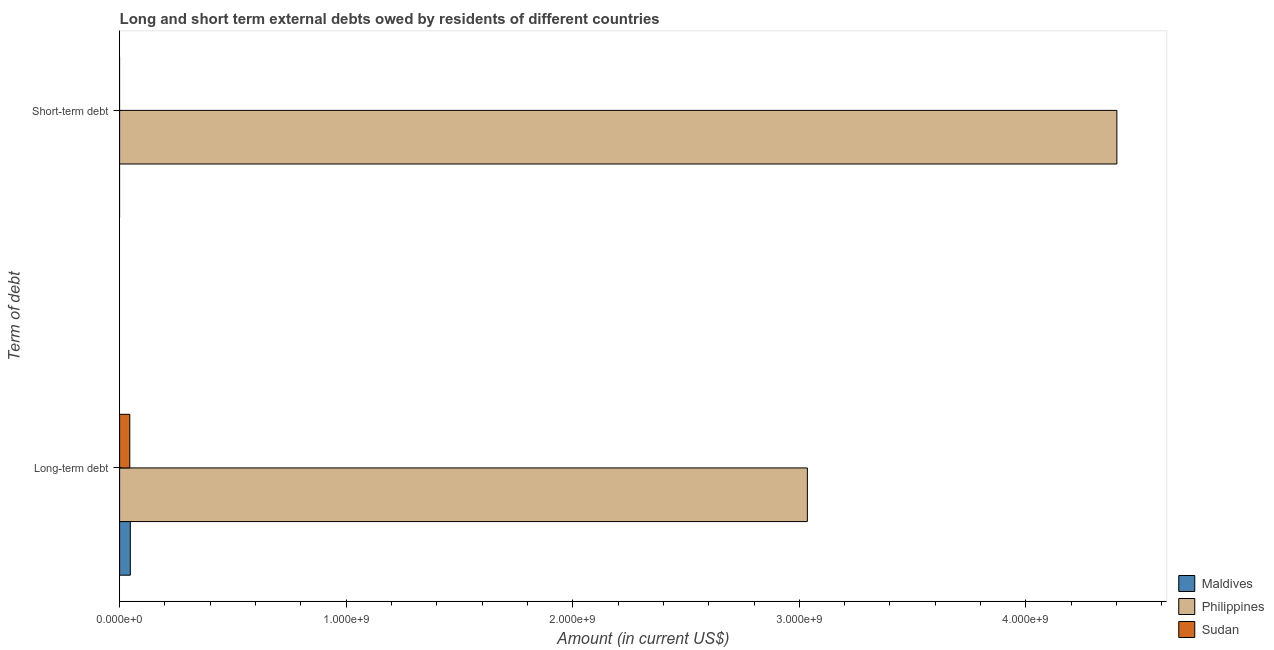Are the number of bars per tick equal to the number of legend labels?
Offer a terse response. No. How many bars are there on the 1st tick from the top?
Your answer should be compact. 1. How many bars are there on the 2nd tick from the bottom?
Provide a succinct answer. 1. What is the label of the 2nd group of bars from the top?
Give a very brief answer. Long-term debt. What is the long-term debts owed by residents in Sudan?
Offer a very short reply. 4.49e+07. Across all countries, what is the maximum short-term debts owed by residents?
Give a very brief answer. 4.40e+09. Across all countries, what is the minimum long-term debts owed by residents?
Keep it short and to the point. 4.49e+07. What is the total long-term debts owed by residents in the graph?
Ensure brevity in your answer.  3.13e+09. What is the difference between the long-term debts owed by residents in Sudan and that in Philippines?
Make the answer very short. -2.99e+09. What is the difference between the short-term debts owed by residents in Maldives and the long-term debts owed by residents in Philippines?
Give a very brief answer. -3.04e+09. What is the average short-term debts owed by residents per country?
Offer a terse response. 1.47e+09. What is the difference between the long-term debts owed by residents and short-term debts owed by residents in Philippines?
Your answer should be compact. -1.37e+09. In how many countries, is the long-term debts owed by residents greater than 400000000 US$?
Your answer should be compact. 1. What is the ratio of the long-term debts owed by residents in Sudan to that in Philippines?
Make the answer very short. 0.01. How many bars are there?
Make the answer very short. 4. Are all the bars in the graph horizontal?
Make the answer very short. Yes. What is the difference between two consecutive major ticks on the X-axis?
Offer a terse response. 1.00e+09. Does the graph contain any zero values?
Offer a terse response. Yes. Does the graph contain grids?
Make the answer very short. No. Where does the legend appear in the graph?
Offer a very short reply. Bottom right. How many legend labels are there?
Offer a very short reply. 3. What is the title of the graph?
Offer a very short reply. Long and short term external debts owed by residents of different countries. What is the label or title of the X-axis?
Offer a terse response. Amount (in current US$). What is the label or title of the Y-axis?
Make the answer very short. Term of debt. What is the Amount (in current US$) in Maldives in Long-term debt?
Provide a short and direct response. 4.72e+07. What is the Amount (in current US$) of Philippines in Long-term debt?
Your answer should be very brief. 3.04e+09. What is the Amount (in current US$) in Sudan in Long-term debt?
Give a very brief answer. 4.49e+07. What is the Amount (in current US$) of Maldives in Short-term debt?
Your answer should be very brief. 0. What is the Amount (in current US$) in Philippines in Short-term debt?
Keep it short and to the point. 4.40e+09. What is the Amount (in current US$) in Sudan in Short-term debt?
Provide a succinct answer. 0. Across all Term of debt, what is the maximum Amount (in current US$) in Maldives?
Keep it short and to the point. 4.72e+07. Across all Term of debt, what is the maximum Amount (in current US$) of Philippines?
Make the answer very short. 4.40e+09. Across all Term of debt, what is the maximum Amount (in current US$) in Sudan?
Your response must be concise. 4.49e+07. Across all Term of debt, what is the minimum Amount (in current US$) of Maldives?
Provide a short and direct response. 0. Across all Term of debt, what is the minimum Amount (in current US$) in Philippines?
Your answer should be very brief. 3.04e+09. Across all Term of debt, what is the minimum Amount (in current US$) of Sudan?
Provide a succinct answer. 0. What is the total Amount (in current US$) in Maldives in the graph?
Offer a terse response. 4.72e+07. What is the total Amount (in current US$) of Philippines in the graph?
Provide a succinct answer. 7.44e+09. What is the total Amount (in current US$) in Sudan in the graph?
Ensure brevity in your answer.  4.49e+07. What is the difference between the Amount (in current US$) of Philippines in Long-term debt and that in Short-term debt?
Provide a succinct answer. -1.37e+09. What is the difference between the Amount (in current US$) of Maldives in Long-term debt and the Amount (in current US$) of Philippines in Short-term debt?
Give a very brief answer. -4.35e+09. What is the average Amount (in current US$) of Maldives per Term of debt?
Your answer should be very brief. 2.36e+07. What is the average Amount (in current US$) in Philippines per Term of debt?
Give a very brief answer. 3.72e+09. What is the average Amount (in current US$) in Sudan per Term of debt?
Give a very brief answer. 2.25e+07. What is the difference between the Amount (in current US$) in Maldives and Amount (in current US$) in Philippines in Long-term debt?
Offer a terse response. -2.99e+09. What is the difference between the Amount (in current US$) of Maldives and Amount (in current US$) of Sudan in Long-term debt?
Provide a short and direct response. 2.29e+06. What is the difference between the Amount (in current US$) in Philippines and Amount (in current US$) in Sudan in Long-term debt?
Make the answer very short. 2.99e+09. What is the ratio of the Amount (in current US$) of Philippines in Long-term debt to that in Short-term debt?
Give a very brief answer. 0.69. What is the difference between the highest and the second highest Amount (in current US$) of Philippines?
Provide a succinct answer. 1.37e+09. What is the difference between the highest and the lowest Amount (in current US$) in Maldives?
Keep it short and to the point. 4.72e+07. What is the difference between the highest and the lowest Amount (in current US$) in Philippines?
Provide a succinct answer. 1.37e+09. What is the difference between the highest and the lowest Amount (in current US$) in Sudan?
Provide a succinct answer. 4.49e+07. 